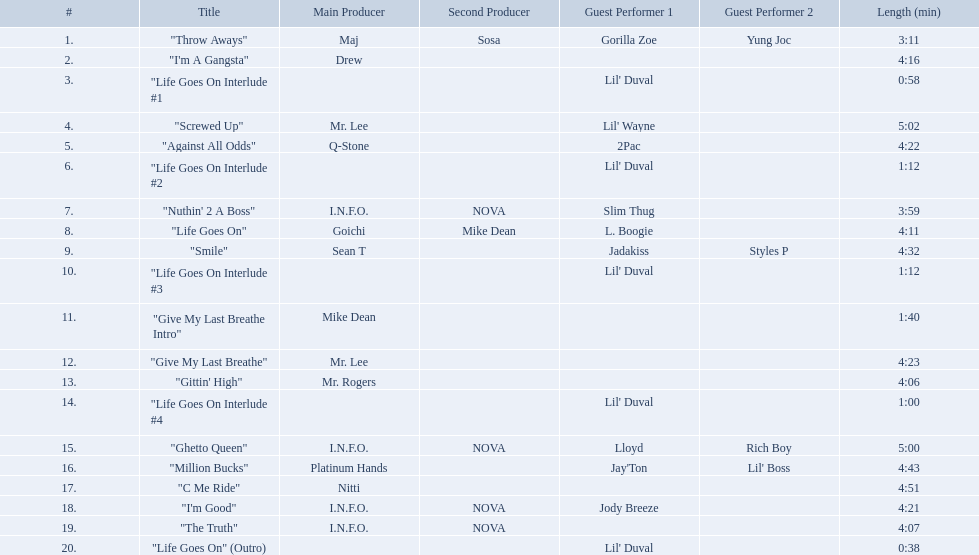What are the song lengths of all the songs on the album? 3:11, 4:16, 0:58, 5:02, 4:22, 1:12, 3:59, 4:11, 4:32, 1:12, 1:40, 4:23, 4:06, 1:00, 5:00, 4:43, 4:51, 4:21, 4:07, 0:38. Which is the longest of these? 5:02. Which tracks are longer than 4.00? "I'm A Gangsta", "Screwed Up", "Against All Odds", "Life Goes On", "Smile", "Give My Last Breathe", "Gittin' High", "Ghetto Queen", "Million Bucks", "C Me Ride", "I'm Good", "The Truth". Of those, which tracks are longer than 4.30? "Screwed Up", "Smile", "Ghetto Queen", "Million Bucks", "C Me Ride". Of those, which tracks are 5.00 or longer? "Screwed Up", "Ghetto Queen". Of those, which one is the longest? "Screwed Up". How long is that track? 5:02. 